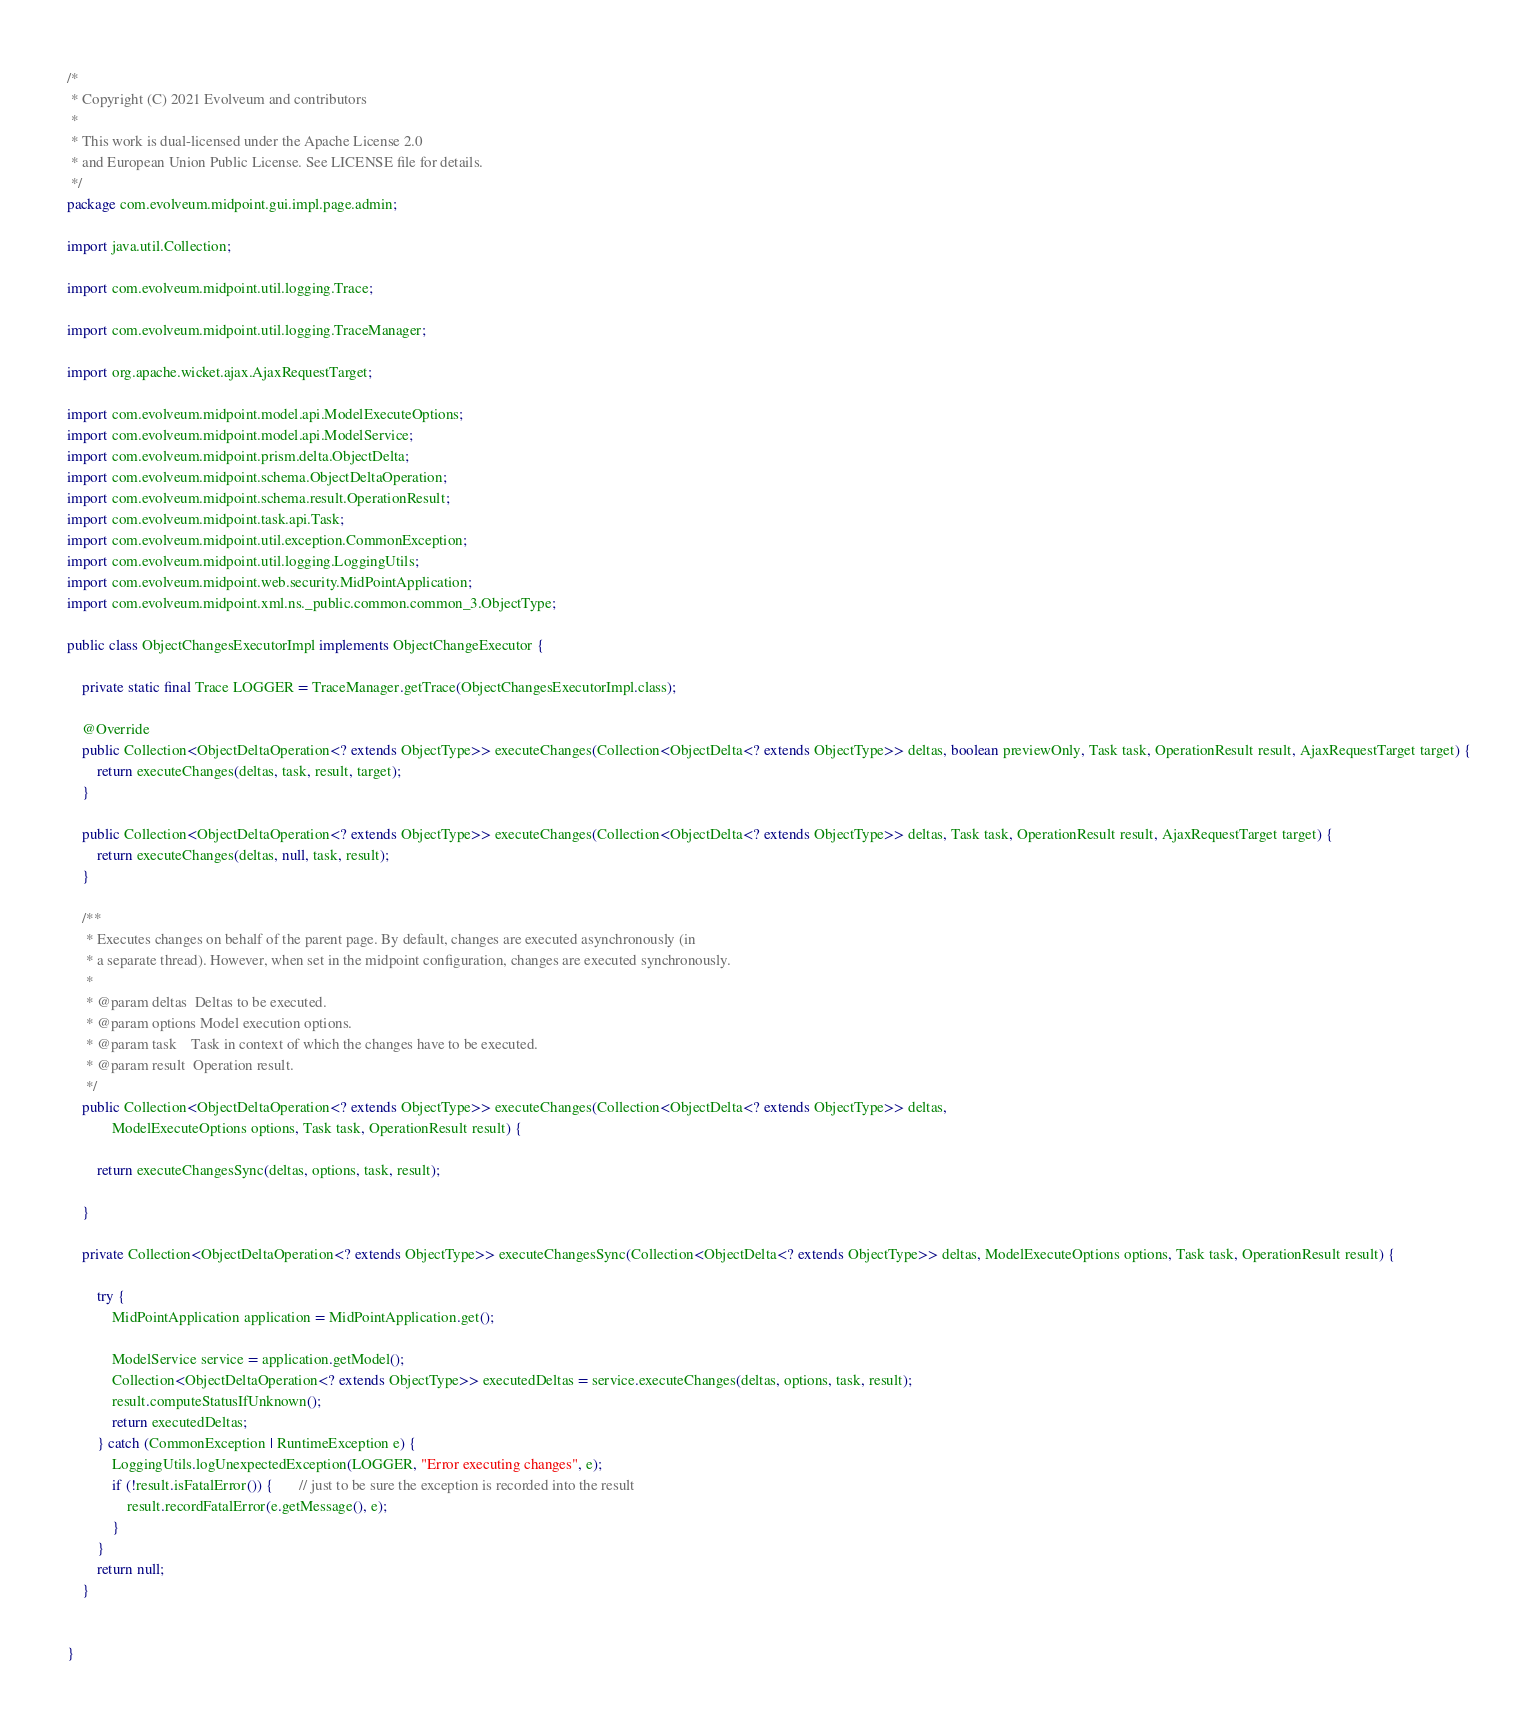Convert code to text. <code><loc_0><loc_0><loc_500><loc_500><_Java_>/*
 * Copyright (C) 2021 Evolveum and contributors
 *
 * This work is dual-licensed under the Apache License 2.0
 * and European Union Public License. See LICENSE file for details.
 */
package com.evolveum.midpoint.gui.impl.page.admin;

import java.util.Collection;

import com.evolveum.midpoint.util.logging.Trace;

import com.evolveum.midpoint.util.logging.TraceManager;

import org.apache.wicket.ajax.AjaxRequestTarget;

import com.evolveum.midpoint.model.api.ModelExecuteOptions;
import com.evolveum.midpoint.model.api.ModelService;
import com.evolveum.midpoint.prism.delta.ObjectDelta;
import com.evolveum.midpoint.schema.ObjectDeltaOperation;
import com.evolveum.midpoint.schema.result.OperationResult;
import com.evolveum.midpoint.task.api.Task;
import com.evolveum.midpoint.util.exception.CommonException;
import com.evolveum.midpoint.util.logging.LoggingUtils;
import com.evolveum.midpoint.web.security.MidPointApplication;
import com.evolveum.midpoint.xml.ns._public.common.common_3.ObjectType;

public class ObjectChangesExecutorImpl implements ObjectChangeExecutor {

    private static final Trace LOGGER = TraceManager.getTrace(ObjectChangesExecutorImpl.class);

    @Override
    public Collection<ObjectDeltaOperation<? extends ObjectType>> executeChanges(Collection<ObjectDelta<? extends ObjectType>> deltas, boolean previewOnly, Task task, OperationResult result, AjaxRequestTarget target) {
        return executeChanges(deltas, task, result, target);
    }

    public Collection<ObjectDeltaOperation<? extends ObjectType>> executeChanges(Collection<ObjectDelta<? extends ObjectType>> deltas, Task task, OperationResult result, AjaxRequestTarget target) {
        return executeChanges(deltas, null, task, result);
    }

    /**
     * Executes changes on behalf of the parent page. By default, changes are executed asynchronously (in
     * a separate thread). However, when set in the midpoint configuration, changes are executed synchronously.
     *
     * @param deltas  Deltas to be executed.
     * @param options Model execution options.
     * @param task    Task in context of which the changes have to be executed.
     * @param result  Operation result.
     */
    public Collection<ObjectDeltaOperation<? extends ObjectType>> executeChanges(Collection<ObjectDelta<? extends ObjectType>> deltas,
            ModelExecuteOptions options, Task task, OperationResult result) {

        return executeChangesSync(deltas, options, task, result);

    }

    private Collection<ObjectDeltaOperation<? extends ObjectType>> executeChangesSync(Collection<ObjectDelta<? extends ObjectType>> deltas, ModelExecuteOptions options, Task task, OperationResult result) {

        try {
            MidPointApplication application = MidPointApplication.get();

            ModelService service = application.getModel();
            Collection<ObjectDeltaOperation<? extends ObjectType>> executedDeltas = service.executeChanges(deltas, options, task, result);
            result.computeStatusIfUnknown();
            return executedDeltas;
        } catch (CommonException | RuntimeException e) {
            LoggingUtils.logUnexpectedException(LOGGER, "Error executing changes", e);
            if (!result.isFatalError()) {       // just to be sure the exception is recorded into the result
                result.recordFatalError(e.getMessage(), e);
            }
        }
        return null;
    }


}
</code> 